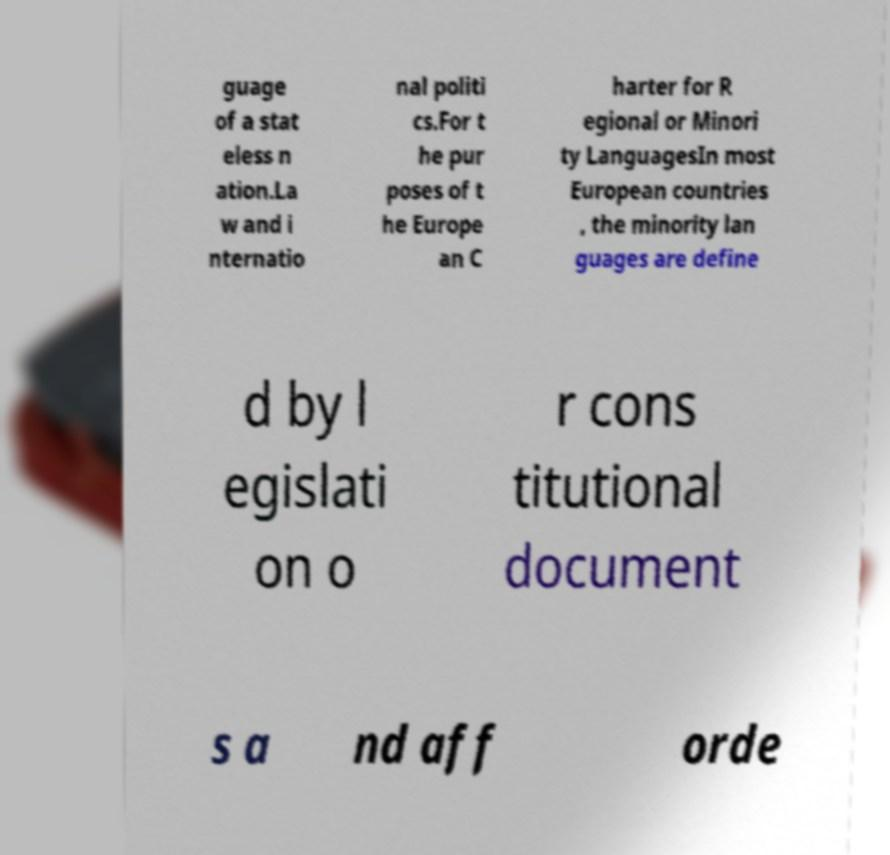Please identify and transcribe the text found in this image. guage of a stat eless n ation.La w and i nternatio nal politi cs.For t he pur poses of t he Europe an C harter for R egional or Minori ty LanguagesIn most European countries , the minority lan guages are define d by l egislati on o r cons titutional document s a nd aff orde 